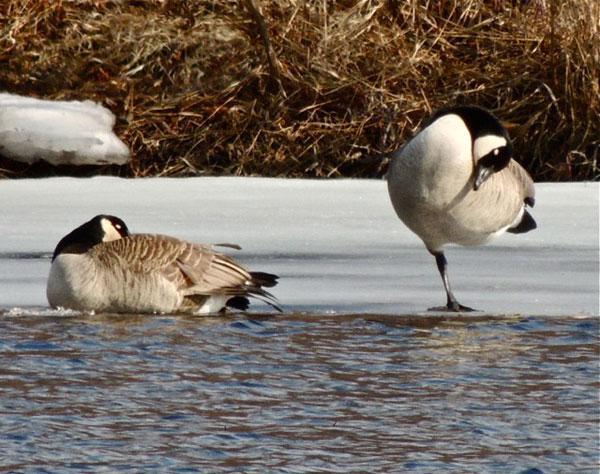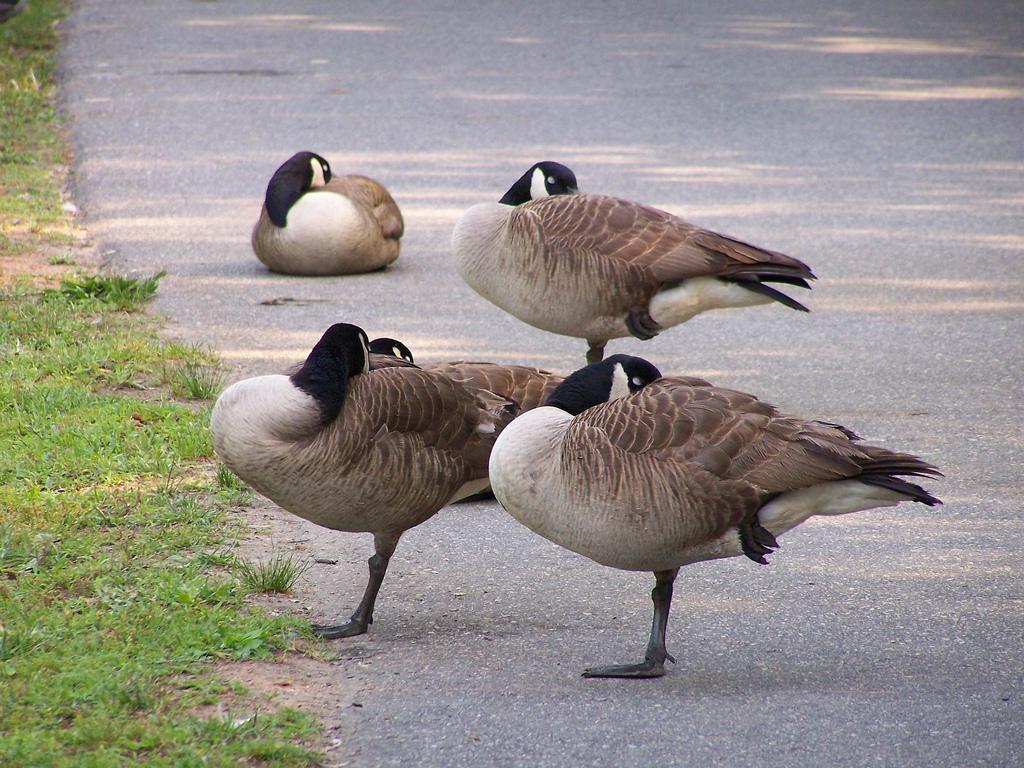The first image is the image on the left, the second image is the image on the right. Assess this claim about the two images: "A single bird has its head in its feathers.". Correct or not? Answer yes or no. No. The first image is the image on the left, the second image is the image on the right. Assess this claim about the two images: "There are two birds in total.". Correct or not? Answer yes or no. No. 